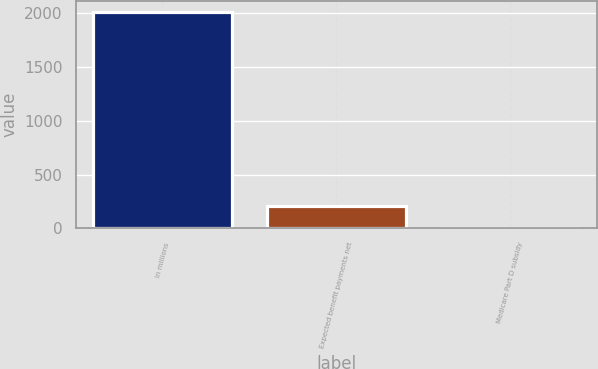<chart> <loc_0><loc_0><loc_500><loc_500><bar_chart><fcel>In millions<fcel>Expected benefit payments net<fcel>Medicare Part D subsidy<nl><fcel>2011<fcel>203.8<fcel>3<nl></chart> 